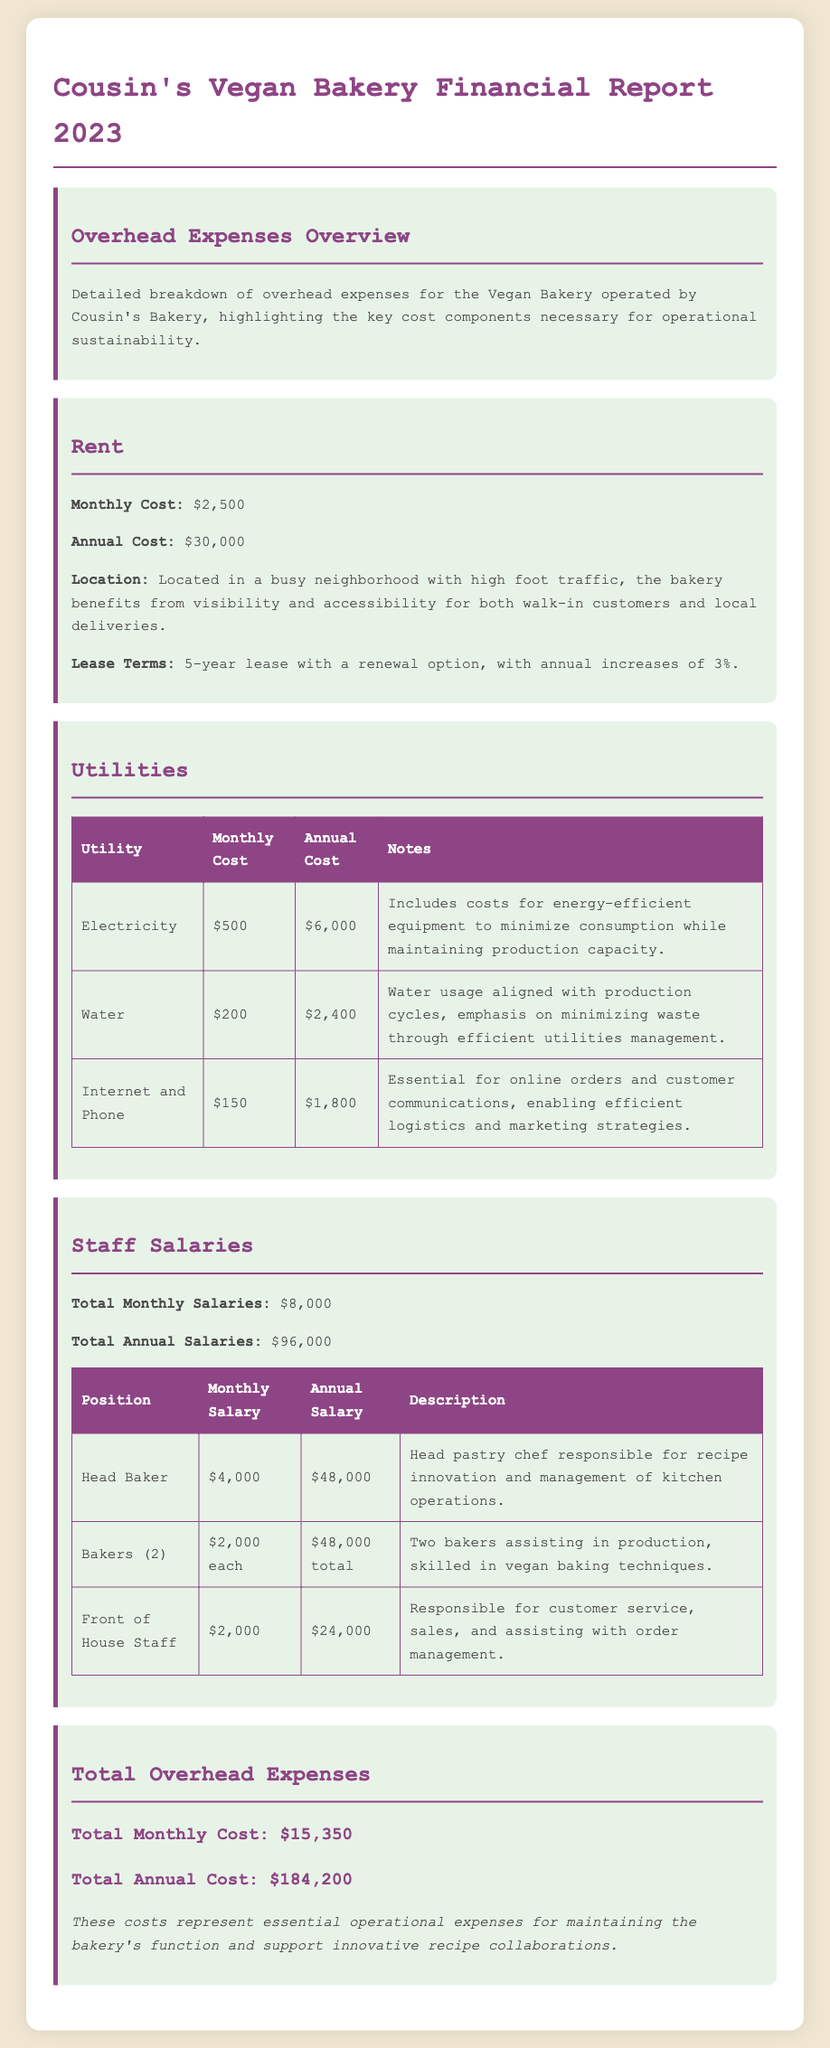what is the monthly rent cost? The monthly rent cost is specifically stated in the document as $2,500.
Answer: $2,500 what is the total annual salary for the Head Baker? The annual salary for the Head Baker is mentioned in the document as $48,000.
Answer: $48,000 how much is the monthly utility cost for electricity? The document indicates that the monthly utility cost for electricity is $500.
Answer: $500 what is the total monthly cost of all overhead expenses? The total monthly cost of all overhead expenses is summarized in the document as $15,350.
Answer: $15,350 how many bakers are employed at the bakery? The document states that there are two bakers employed at the bakery.
Answer: two what percentage increase is included in the lease terms for rent? The lease terms include a 3% annual increase, as specified in the document.
Answer: 3% what are the total annual utility costs listed in the document? The total of the annual utility costs is calculated as the sum of each utility's annual cost in the document.
Answer: $10,200 what is the purpose of the Internet and Phone utility? The purpose of the Internet and Phone utility is stated as essential for online orders and customer communications.
Answer: essential for online orders and customer communications how long is the lease term for the bakery's location? The lease term for the bakery's location is specified in the document as a 5-year lease.
Answer: 5-year lease 